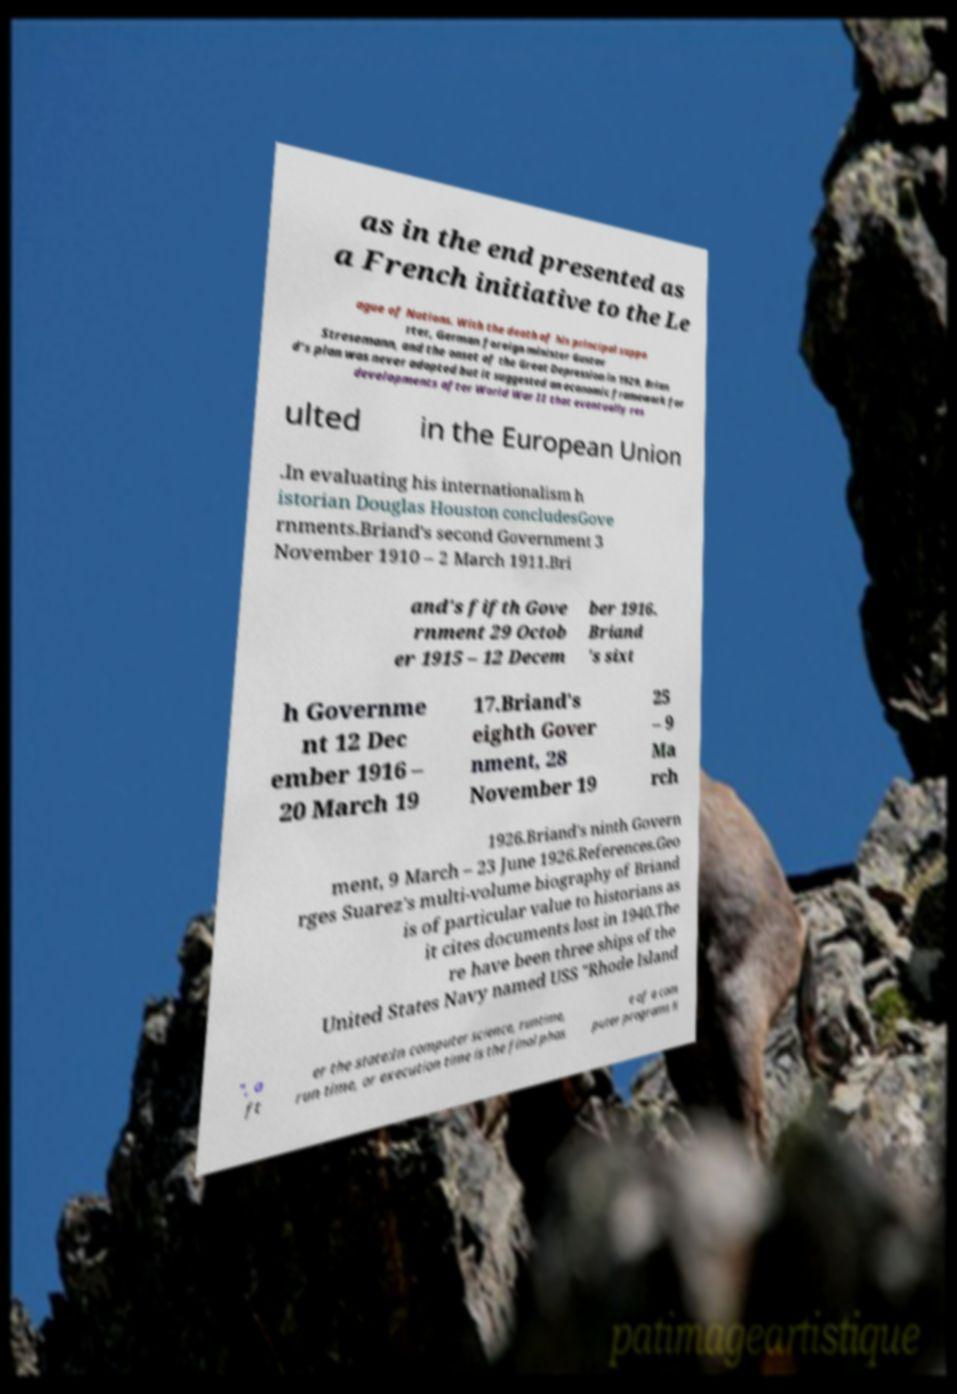Please read and relay the text visible in this image. What does it say? as in the end presented as a French initiative to the Le ague of Nations. With the death of his principal suppo rter, German foreign minister Gustav Stresemann, and the onset of the Great Depression in 1929, Brian d's plan was never adopted but it suggested an economic framework for developments after World War II that eventually res ulted in the European Union .In evaluating his internationalism h istorian Douglas Houston concludesGove rnments.Briand's second Government 3 November 1910 – 2 March 1911.Bri and's fifth Gove rnment 29 Octob er 1915 – 12 Decem ber 1916. Briand 's sixt h Governme nt 12 Dec ember 1916 – 20 March 19 17.Briand's eighth Gover nment, 28 November 19 25 – 9 Ma rch 1926.Briand's ninth Govern ment, 9 March – 23 June 1926.References.Geo rges Suarez's multi-volume biography of Briand is of particular value to historians as it cites documents lost in 1940.The re have been three ships of the United States Navy named USS "Rhode Island ", a ft er the state:In computer science, runtime, run time, or execution time is the final phas e of a com puter programs li 